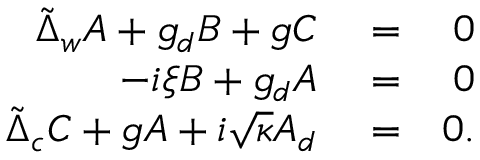<formula> <loc_0><loc_0><loc_500><loc_500>\begin{array} { r l r } { \tilde { \Delta } _ { w } A + g _ { d } B + g C } & = } & { 0 } \\ { - i \xi B + g _ { d } A } & = } & { 0 } \\ { \tilde { \Delta } _ { c } C + g A + i \sqrt { \kappa } A _ { d } } & = } & { 0 . } \end{array}</formula> 